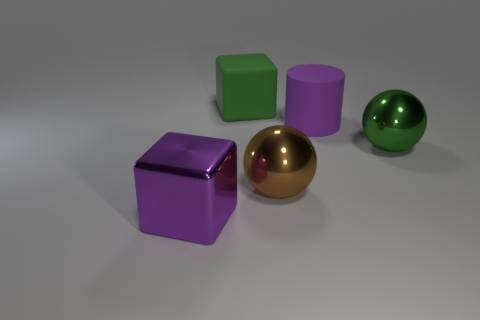What is the material of the other big thing that is the same shape as the brown shiny object?
Your response must be concise. Metal. How many other brown shiny objects are the same size as the brown shiny thing?
Offer a terse response. 0. What number of big cyan shiny balls are there?
Offer a terse response. 0. Do the big cylinder and the sphere on the left side of the green shiny thing have the same material?
Your answer should be very brief. No. What number of cyan objects are big balls or metallic cubes?
Ensure brevity in your answer.  0. The purple thing that is the same material as the green block is what size?
Your answer should be compact. Large. How many green shiny things are the same shape as the brown object?
Give a very brief answer. 1. Are there more big matte cylinders in front of the green sphere than purple things that are to the left of the large purple block?
Your answer should be compact. No. Do the matte cube and the big object to the right of the purple matte thing have the same color?
Make the answer very short. Yes. There is a green cube that is the same size as the cylinder; what is it made of?
Provide a short and direct response. Rubber. 